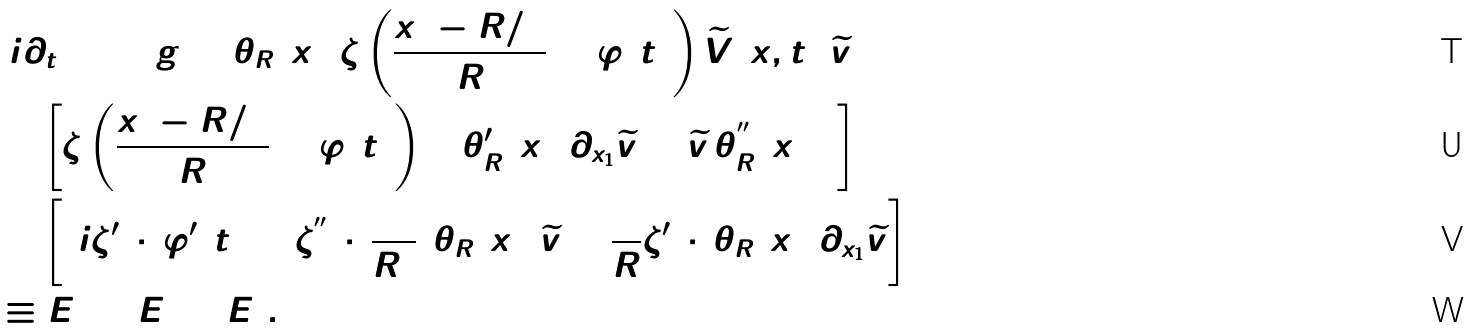Convert formula to latex. <formula><loc_0><loc_0><loc_500><loc_500>& ( i \partial _ { t } + \Delta ) g = \theta _ { R } ( x _ { 1 } ) \zeta \left ( \frac { x _ { 1 } - R / 2 } { R } + \varphi ( t ) \right ) \widetilde { V } ( x , t ) \, \widetilde { v } \\ & + \left [ \zeta \left ( \frac { x _ { 1 } - R / 2 } { R } + \varphi ( t ) \right ) ( 2 \theta _ { R } ^ { \prime } ( x _ { 1 } ) \partial _ { x _ { 1 } } \widetilde { v } + \widetilde { v } \, \theta _ { R } ^ { ^ { \prime \prime } } ( x _ { 1 } ) ) \right ] \\ & + \left [ ( i \zeta ^ { \prime } ( \cdot ) \varphi ^ { \prime } ( t ) + \zeta ^ { ^ { \prime \prime } } ( \cdot ) \frac { 1 } { R ^ { 2 } } ) \theta _ { R } ( x _ { 1 } ) \widetilde { v } + \frac { 2 } { R } \zeta ^ { \prime } ( \cdot ) \theta _ { R } ( x _ { 1 } ) \partial _ { x _ { 1 } } \widetilde { v } \right ] \\ & \equiv E _ { 1 } + E _ { 2 } + E _ { 3 } .</formula> 